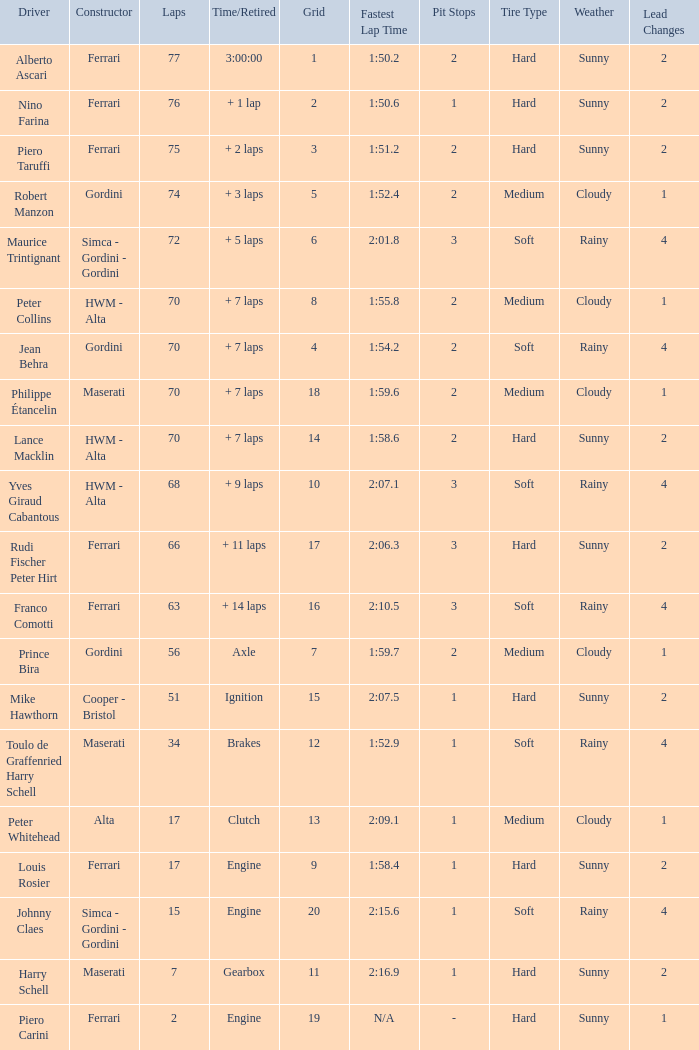Who drove the car with over 66 laps with a grid of 5? Robert Manzon. 